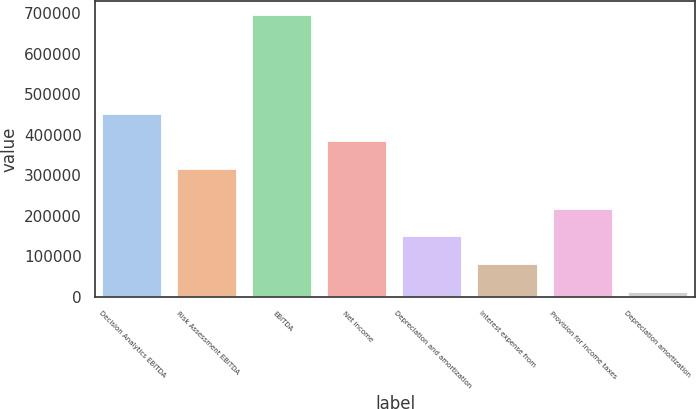Convert chart. <chart><loc_0><loc_0><loc_500><loc_500><bar_chart><fcel>Decision Analytics EBITDA<fcel>Risk Assessment EBITDA<fcel>EBITDA<fcel>Net income<fcel>Depreciation and amortization<fcel>Interest expense from<fcel>Provision for income taxes<fcel>Depreciation amortization<nl><fcel>452831<fcel>316260<fcel>695915<fcel>384546<fcel>149629<fcel>81343.7<fcel>217915<fcel>13058<nl></chart> 